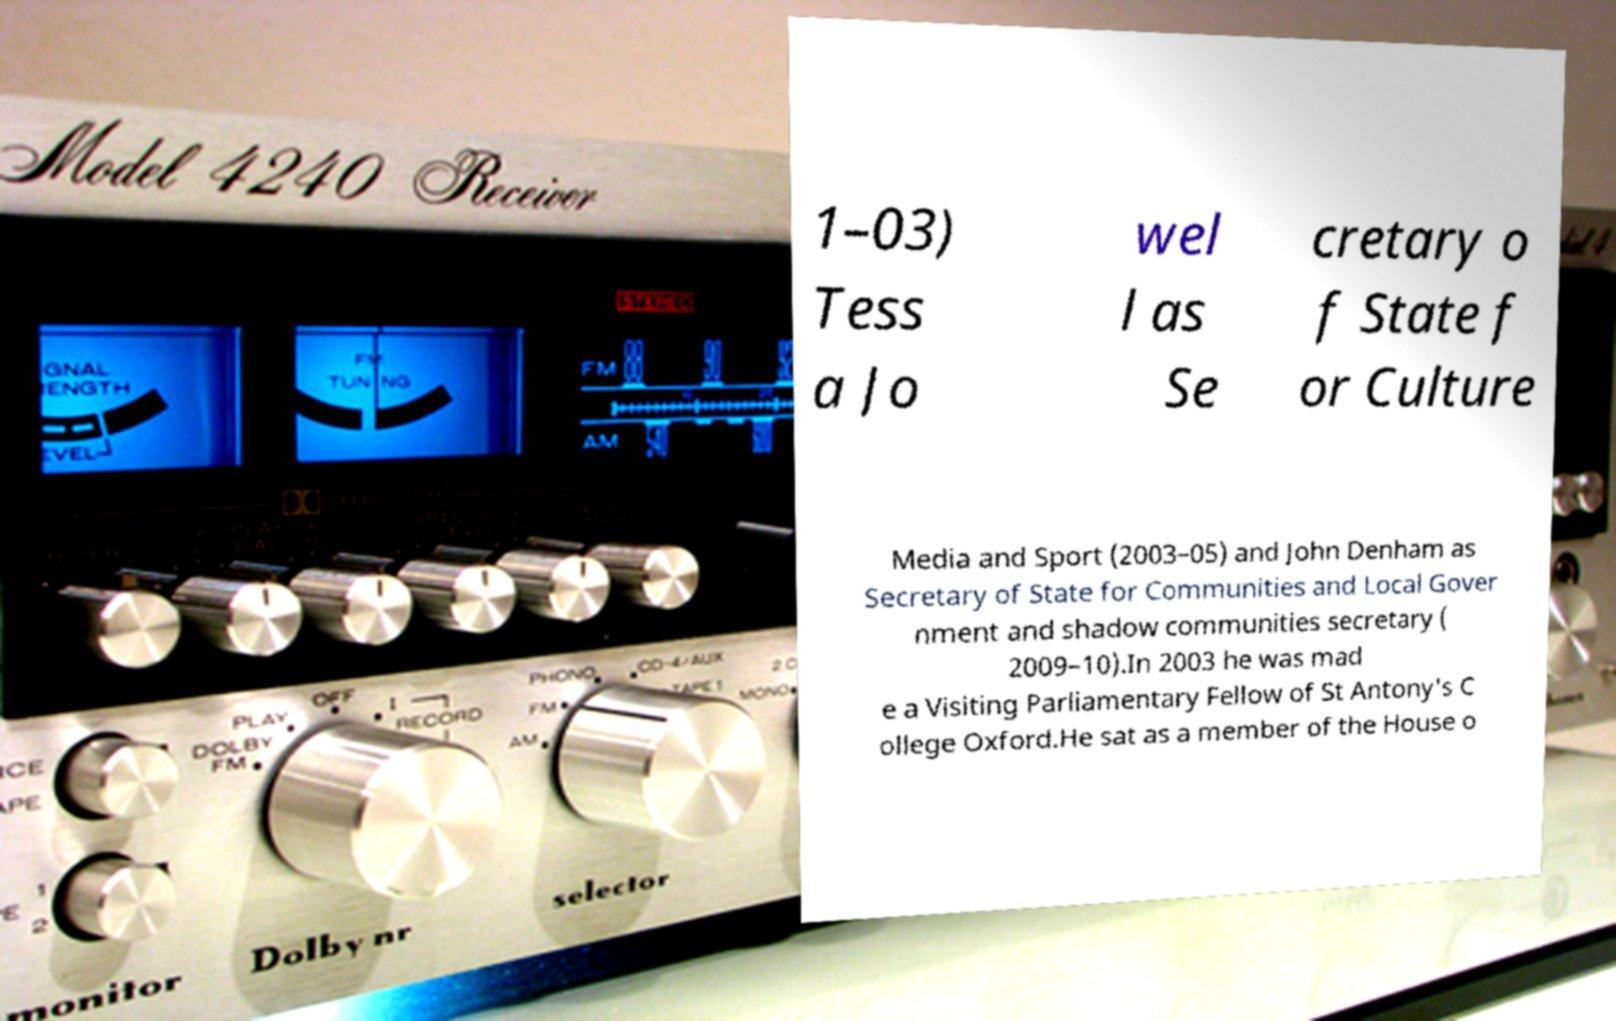Could you assist in decoding the text presented in this image and type it out clearly? 1–03) Tess a Jo wel l as Se cretary o f State f or Culture Media and Sport (2003–05) and John Denham as Secretary of State for Communities and Local Gover nment and shadow communities secretary ( 2009–10).In 2003 he was mad e a Visiting Parliamentary Fellow of St Antony's C ollege Oxford.He sat as a member of the House o 